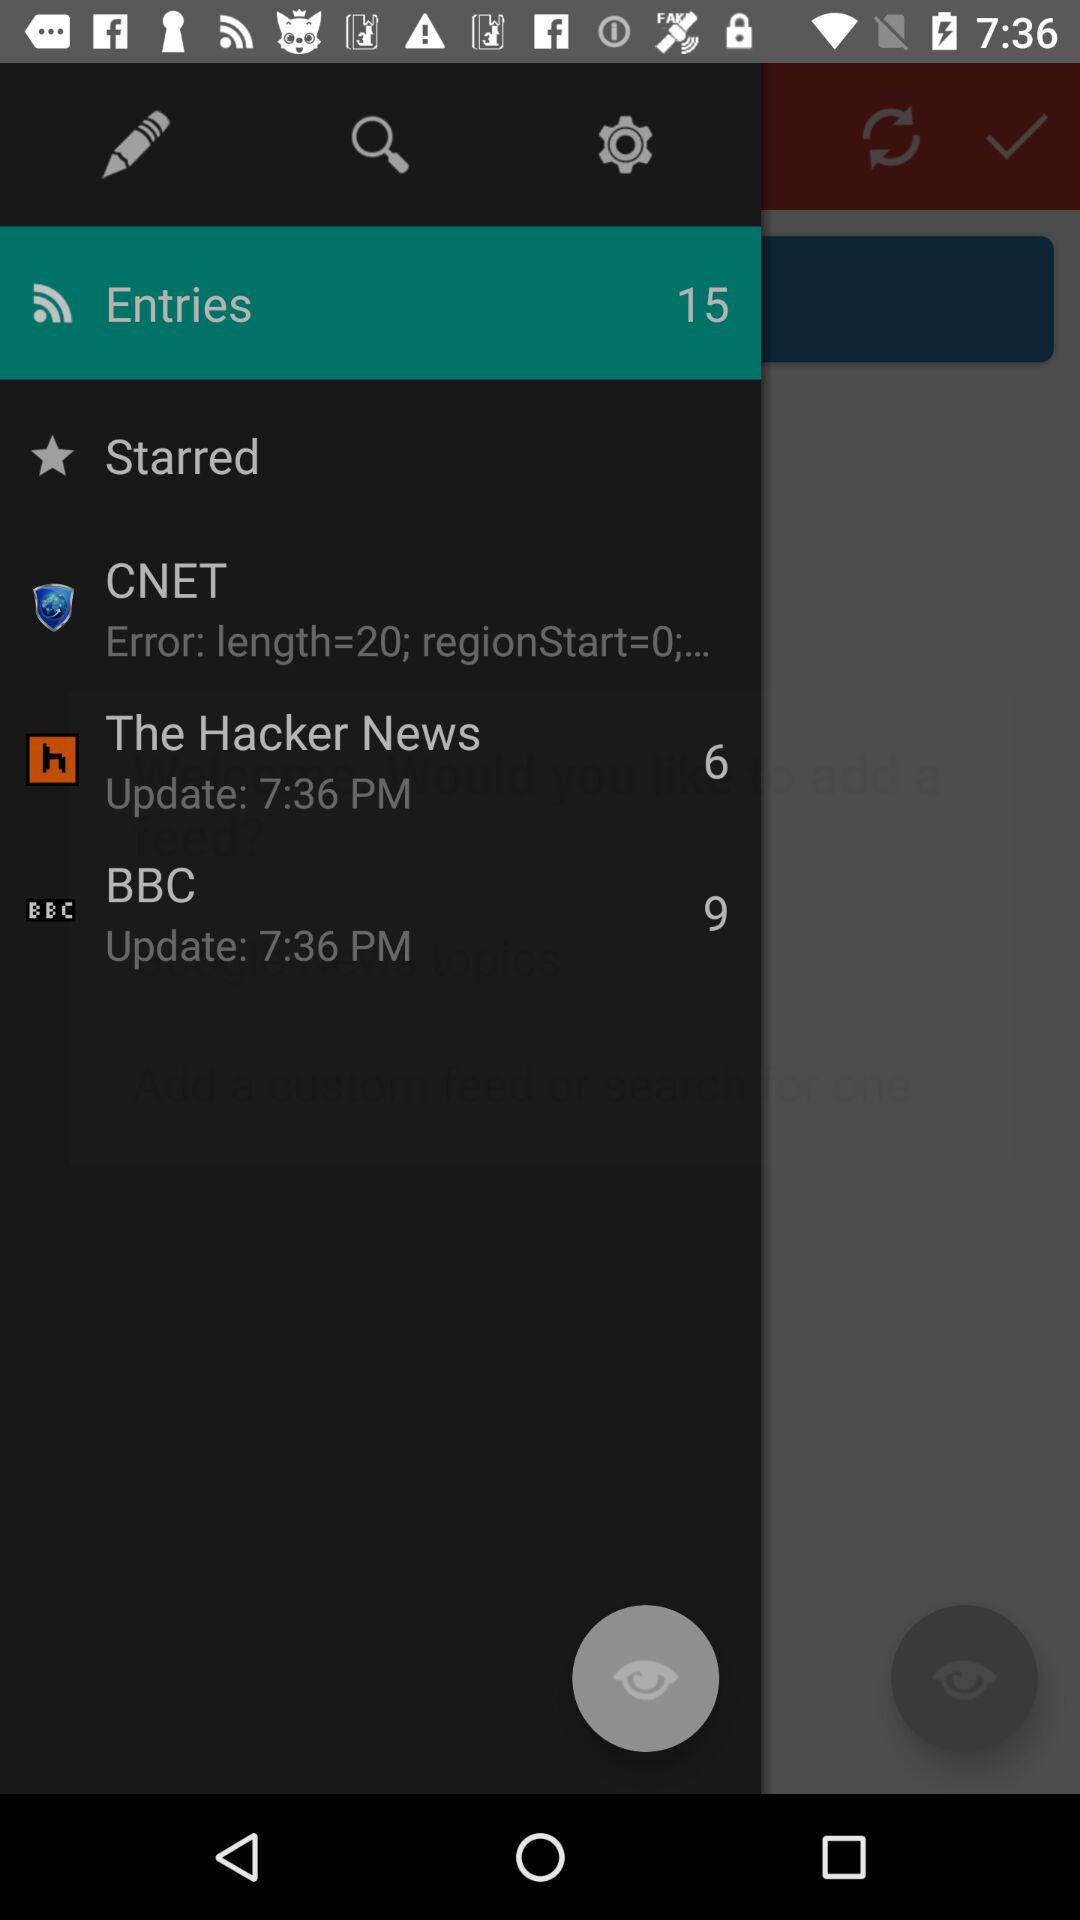How many entries are there? There are 15 entries. 